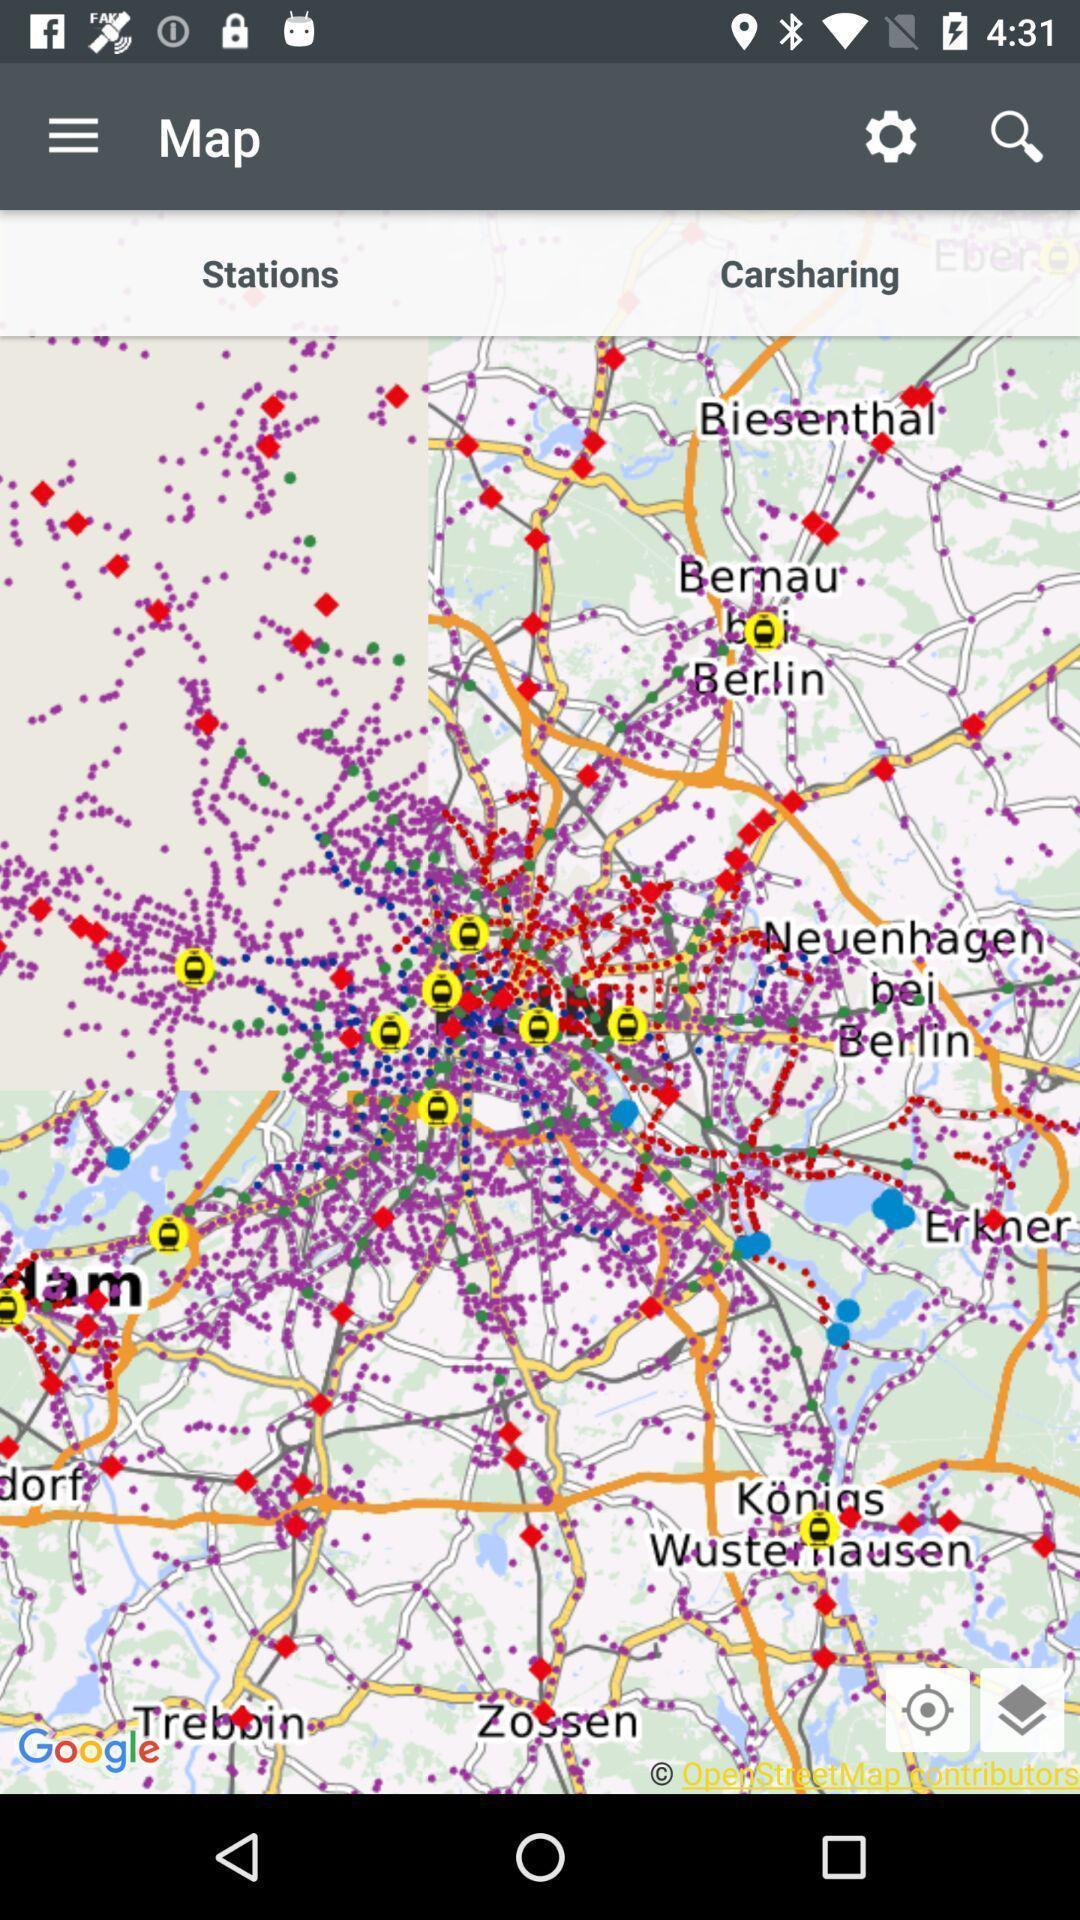Provide a description of this screenshot. Screen page displaying a map with various options. 